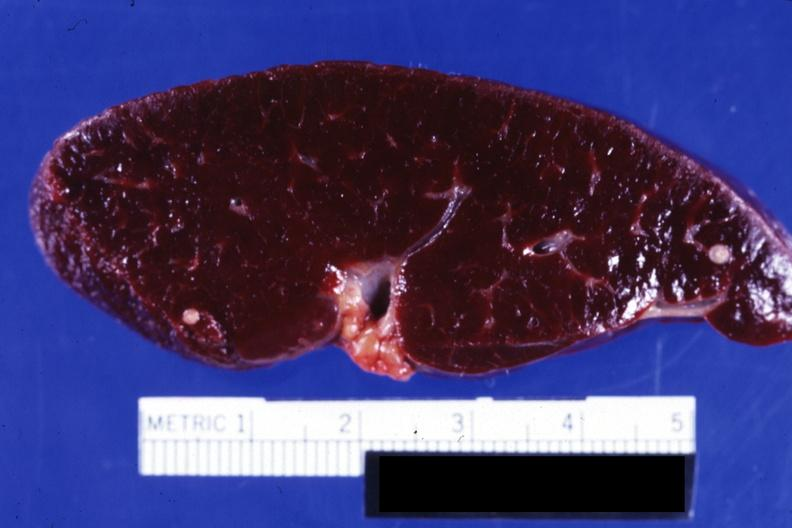what does this image show?
Answer the question using a single word or phrase. Close-up of cut surface showing two typical old granulomas 